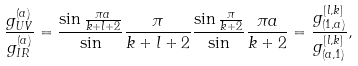<formula> <loc_0><loc_0><loc_500><loc_500>\frac { g _ { U V } ^ { ( a ) } } { g _ { I R } ^ { ( a ) } } = \frac { \sin \frac { \pi a } { k + l + 2 } } \sin \frac { \pi } { k + l + 2 } \frac { \sin \frac { \pi } { k + 2 } } \sin \frac { \pi a } { k + 2 } = \frac { g _ { ( 1 , a ) } ^ { [ l , k ] } } { g _ { ( a , 1 ) } ^ { [ l , k ] } } ,</formula> 